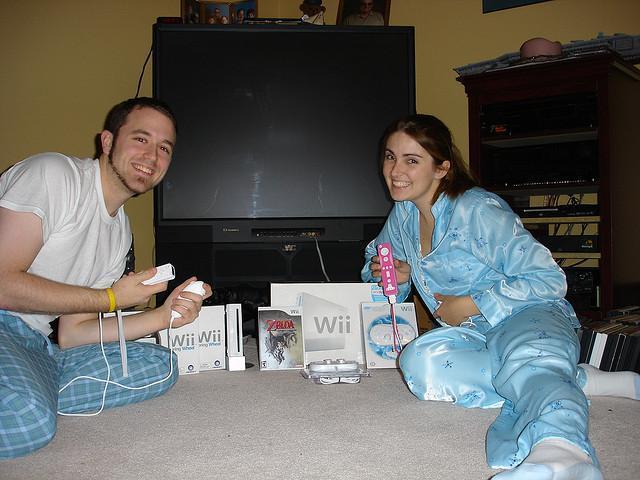How many people are in the picture?
Give a very brief answer. 2. How many umbrellas are there?
Give a very brief answer. 0. 